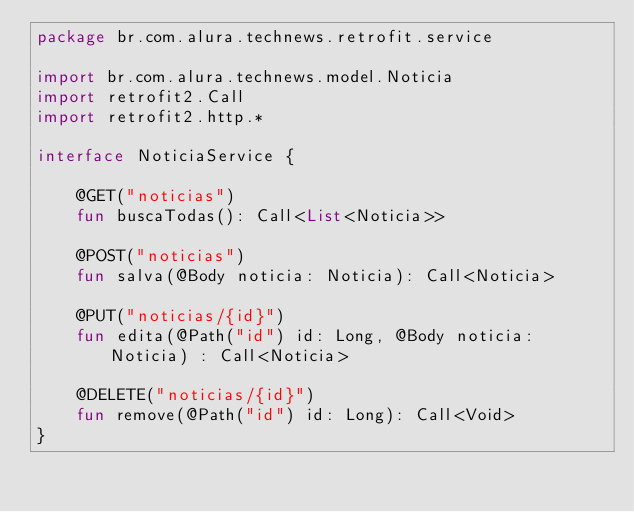<code> <loc_0><loc_0><loc_500><loc_500><_Kotlin_>package br.com.alura.technews.retrofit.service

import br.com.alura.technews.model.Noticia
import retrofit2.Call
import retrofit2.http.*

interface NoticiaService {

    @GET("noticias")
    fun buscaTodas(): Call<List<Noticia>>

    @POST("noticias")
    fun salva(@Body noticia: Noticia): Call<Noticia>

    @PUT("noticias/{id}")
    fun edita(@Path("id") id: Long, @Body noticia: Noticia) : Call<Noticia>

    @DELETE("noticias/{id}")
    fun remove(@Path("id") id: Long): Call<Void>
}
</code> 